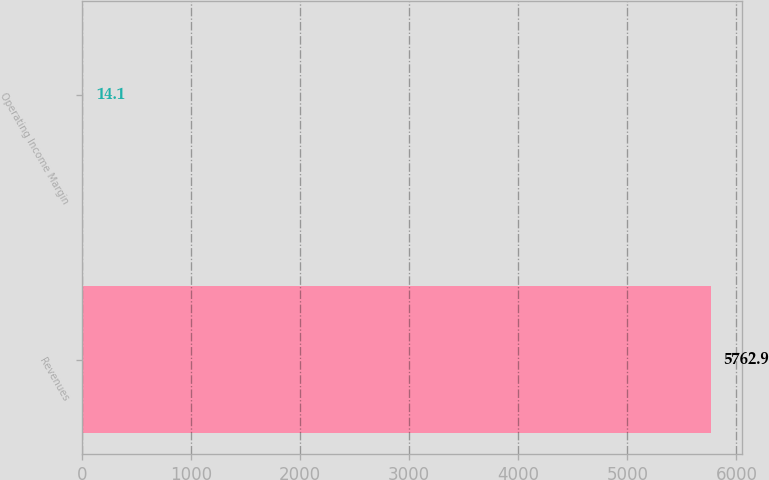<chart> <loc_0><loc_0><loc_500><loc_500><bar_chart><fcel>Revenues<fcel>Operating Income Margin<nl><fcel>5762.9<fcel>14.1<nl></chart> 